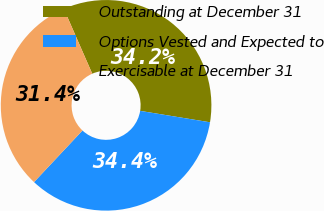<chart> <loc_0><loc_0><loc_500><loc_500><pie_chart><fcel>Outstanding at December 31<fcel>Options Vested and Expected to<fcel>Exercisable at December 31<nl><fcel>34.15%<fcel>34.42%<fcel>31.43%<nl></chart> 